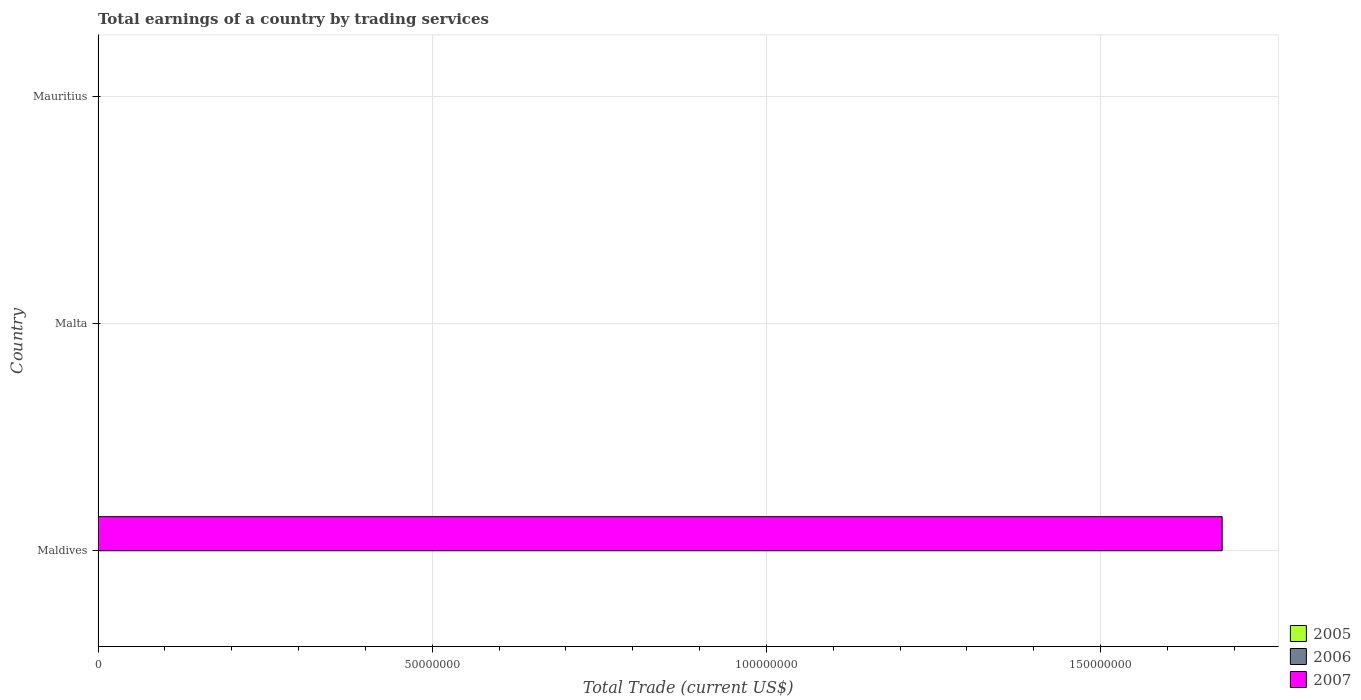How many different coloured bars are there?
Ensure brevity in your answer.  1. How many bars are there on the 1st tick from the top?
Your answer should be very brief. 0. What is the label of the 2nd group of bars from the top?
Your answer should be very brief. Malta. What is the total earnings in 2005 in Mauritius?
Ensure brevity in your answer.  0. Across all countries, what is the maximum total earnings in 2007?
Keep it short and to the point. 1.68e+08. In which country was the total earnings in 2007 maximum?
Provide a short and direct response. Maldives. What is the difference between the total earnings in 2007 in Mauritius and the total earnings in 2006 in Malta?
Your answer should be very brief. 0. What is the average total earnings in 2007 per country?
Offer a terse response. 5.61e+07. How many bars are there?
Keep it short and to the point. 1. Are all the bars in the graph horizontal?
Offer a terse response. Yes. Are the values on the major ticks of X-axis written in scientific E-notation?
Your answer should be compact. No. Does the graph contain any zero values?
Your response must be concise. Yes. Does the graph contain grids?
Make the answer very short. Yes. How are the legend labels stacked?
Give a very brief answer. Vertical. What is the title of the graph?
Your answer should be compact. Total earnings of a country by trading services. Does "2009" appear as one of the legend labels in the graph?
Your response must be concise. No. What is the label or title of the X-axis?
Provide a short and direct response. Total Trade (current US$). What is the Total Trade (current US$) of 2005 in Maldives?
Provide a short and direct response. 0. What is the Total Trade (current US$) in 2007 in Maldives?
Offer a terse response. 1.68e+08. What is the Total Trade (current US$) of 2005 in Malta?
Give a very brief answer. 0. What is the Total Trade (current US$) of 2005 in Mauritius?
Provide a succinct answer. 0. What is the Total Trade (current US$) in 2007 in Mauritius?
Keep it short and to the point. 0. Across all countries, what is the maximum Total Trade (current US$) of 2007?
Provide a succinct answer. 1.68e+08. Across all countries, what is the minimum Total Trade (current US$) in 2007?
Your answer should be very brief. 0. What is the total Total Trade (current US$) of 2007 in the graph?
Give a very brief answer. 1.68e+08. What is the average Total Trade (current US$) of 2007 per country?
Offer a very short reply. 5.61e+07. What is the difference between the highest and the lowest Total Trade (current US$) in 2007?
Make the answer very short. 1.68e+08. 